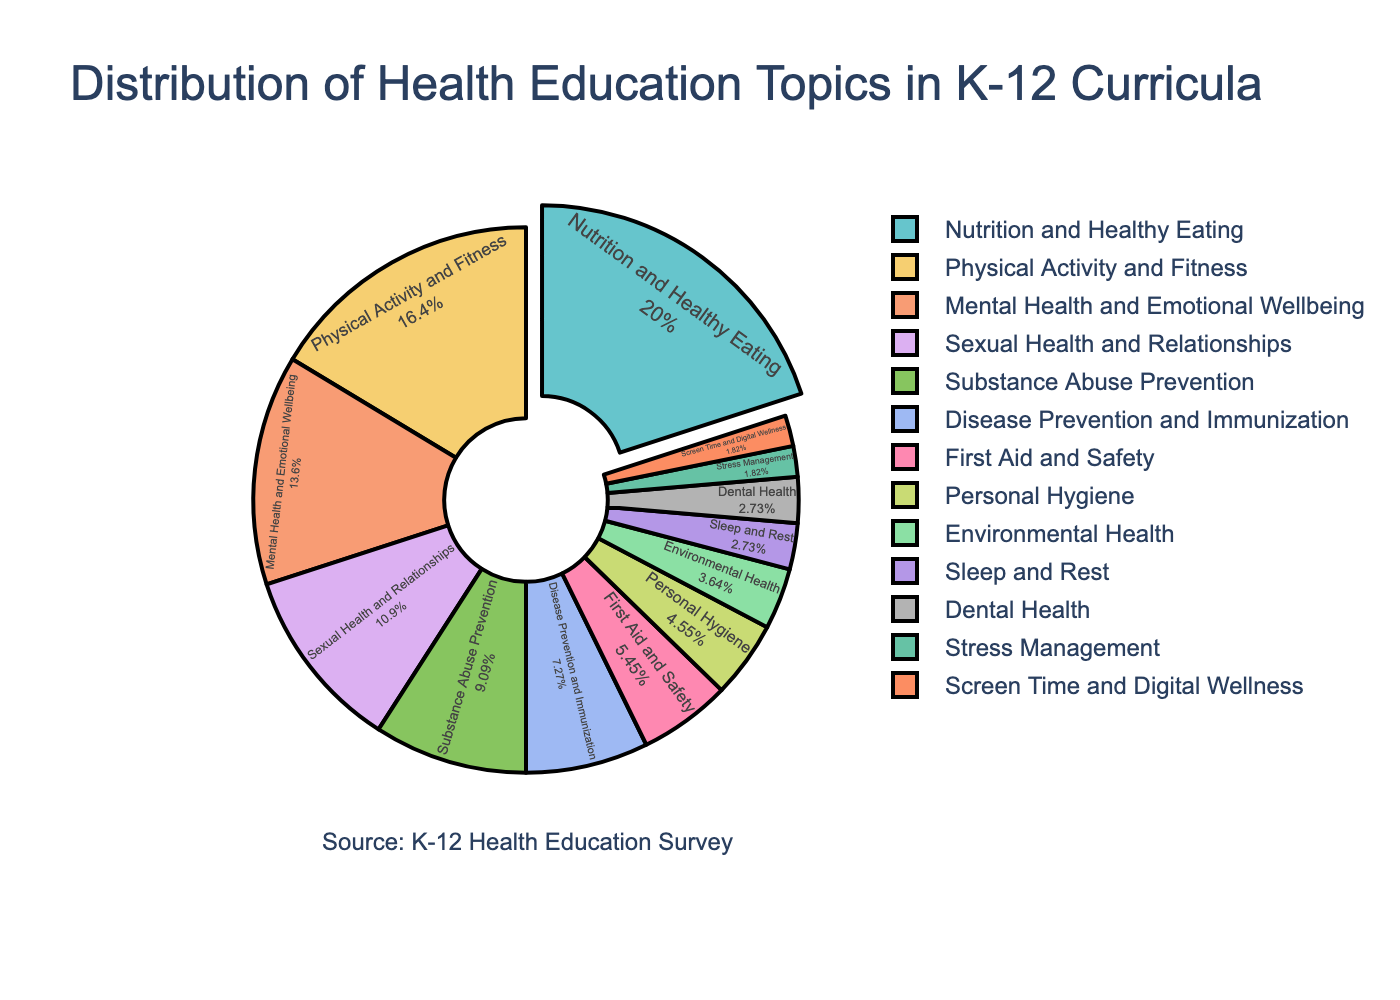Which topic has the highest percentage in the health education curriculum? The topic with the highest percentage is represented by the largest slice in the pie chart. According to the data, this is "Nutrition and Healthy Eating" with 22%.
Answer: Nutrition and Healthy Eating How many topics have a percentage of 10% or more? By examining the slices in the pie chart, we identify the topics that have relatively large slices. These topics and their percentages are: "Nutrition and Healthy Eating" (22%), "Physical Activity and Fitness" (18%), "Mental Health and Emotional Wellbeing" (15%), and "Sexual Health and Relationships" (12%). Counting these, there are 4 topics.
Answer: 4 What is the combined percentage of the three topics with the lowest representation? The three topics with the lowest percentages are "Stress Management" (2%), "Screen Time and Digital Wellness" (2%), and "Sleep and Rest" (3%). Adding these gives us 2% + 2% + 3% = 7%.
Answer: 7% How much greater is the percentage of "Physical Activity and Fitness" compared to "Substance Abuse Prevention"? The percentage for "Physical Activity and Fitness" is 18% and for "Substance Abuse Prevention" it is 10%. The difference is 18% - 10% = 8%.
Answer: 8% Which topic occupies the smallest slice in the pie chart? The smallest slice of the pie chart corresponds to the topic with the smallest percentage. According to the data, this is "Stress Management" and "Screen Time and Digital Wellness" both at 2%.
Answer: Stress Management and Screen Time and Digital Wellness What is the sum of the percentages for "Disease Prevention and Immunization" and "First Aid and Safety"? The percentage for "Disease Prevention and Immunization" is 8%, and for "First Aid and Safety" it is 6%. Adding these gives us 8% + 6% = 14%.
Answer: 14% If we were to group "Mental Health and Emotional Wellbeing" and "Stress Management" together, what would be their combined percentage in the chart? "Mental Health and Emotional Wellbeing" has a percentage of 15%, and "Stress Management" has 2%. The combined percentage is 15% + 2% = 17%.
Answer: 17% Which topics have percentages between 5% and 15%? By examining the slices, the topics with percentages between 5% and 15% are "Mental Health and Emotional Wellbeing" (15%), "Sexual Health and Relationships" (12%), "Substance Abuse Prevention" (10%), "Disease Prevention and Immunization" (8%), and "First Aid and Safety" (6%).
Answer: Mental Health and Emotional Wellbeing, Sexual Health and Relationships, Substance Abuse Prevention, Disease Prevention and Immunization, First Aid and Safety 